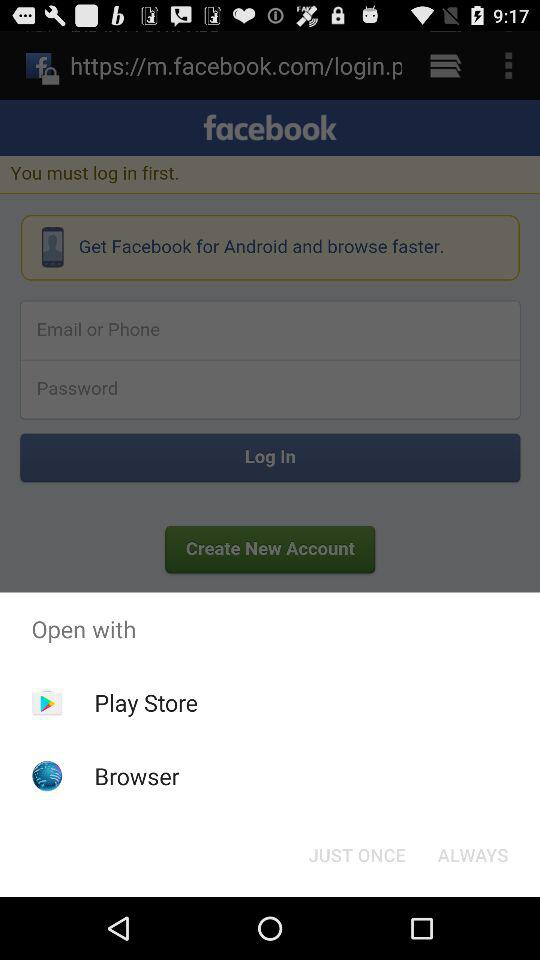Which applications can be used for opening? The applications are "Play Store" and "Browser". 